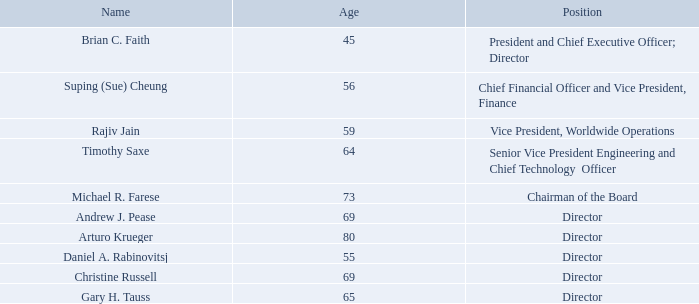Information About Our Executive Officers and Directors
Our executive officers are appointed by, and serve at the discretion of, our Board of Directors. There are no family relationships among our directors and officers.
The following table sets forth certain information concerning our current executive officers and directors as of March 13, 2020:
Brian C. Faith joined QuickLogic in June 1996. Mr. Faith has served as our President and Chief Executive Officer since June 2016 after having served as Vice President of Worldwide Marketing and Vice President of Worldwide Sales & Marketing between 2008 and 2016. Mr. Faith during the last 21 years has held a variety of managerial and executive leadership positions in engineering, product line management, marketing and sales. Mr. Faith has also served as the board member of the Global Semiconductor Alliance (GSA), the Chairman of the Marketing Committee for the CE-ATA Organization. He holds a B.S. degree in Computer Engineering from Santa Clara University and was an Adjunct Lecturer at Santa Clara University for Programmable Logic courses.
Suping (Sue) Cheung (Ph.D.) joined QuickLogic in May 2007. Dr. Cheung has served as our Chief Financial Officer, Vice President of Finance, Chief Accounting Officer, and Principal Accounting Officer since May 2015, Corporate Controller from 2007 to 2018. Prior to joining QuickLogic, Dr. Cheung was a Senior Manager of SEC Reporting, Technical Accounting and International Consolidation at Dell SonicWALL from 2006 to 2007 and was the Senior Accounting Manager at VeriFone System, Inc. from 2005 to 2006. Prior to 2005, Dr. Cheung held various senior accounting and financial management roles in both publicly traded and privately held companies. Dr. Cheung began her career with PricewaterhouseCoopers (PWC) where she served as an auditor and as a tax consultant. Dr. Cheung holds a Ph.D. in Business Administration and a Masters in Accounting from the Florida International University in Miami. She is a Certified Public Accountant.
Rajiv Jain joined QuickLogic in August 1992. Mr. Jain has served as our Vice President of Worldwide Operations since April 2014. Prior to this role, Mr. Jain served as QuickLogic’s Senior Director of Operations and Development Engineering from 2011 to 2014, Senior Director of System Solutions and Process Technology from 2009 to 2011, Director of Process Technology from 1997 to 2009, and Senior Process Technologist from 1992 to 1997. Prior to joining QuickLogic, Mr. Jain was a Senior Yield Engineer at National Semiconductor from 1991 to 1992, where he focused on BiCMOS product yield improvements, and at Monolithic Memories from 1985 to 1988, where he focused on BiPolar product yield and engineering wafer sort improvements. Mr. Jain holds a Master’s degree in Chemical Engineering from the University of California, Berkeley and a B.S. degree in Chemical Engineering from the University of Illinois, Champaign/Urbana.
Timothy Saxe (Ph.D.) joined QuickLogic in May 2001. Dr. Saxe has served as our Senior Vice President of Engineering and Chief Technology Officer since August 2016 and Senior Vice President and Chief Technology Officer since November 2008. Previously, Dr. Saxe has held a variety of executive leadership positions in QuickLogic including Vice President of Engineering and Vice President of Software Engineering. Dr. Saxe was Vice President of FLASH Engineering at Actel Corporation, a semiconductor manufacturing company, from November 2000 to February 2001. Dr. Saxe joined GateField Corporation, a design verification tools and services company formerly known as Zycad, in June 1983 and was a founder of their semiconductor manufacturing division in 1993. Dr. Saxe became GateField’s Chief Executive Officer in February 1999 and served in that capacity until Actel Corporation acquired GateField in November 2000. Dr. Saxe holds a B.S.E.E. degree from North Carolina State University, and an M.S.E.E. degree and a Ph.D. in Electrical Engineering from Stanford University.
Information regarding the backgrounds of our directors is set forth under the caption “Proposal One, Election of Directors” in our Proxy Statement, which information is incorporated herein by reference.
What are the respective names of the company's President and Chief Financial Officer? Brian c. faith, suping (sue) cheung. What are the respective names of the company's Vice President of Worldwide Operations and Chief Executive Officer? Rajiv jain, brian c. faith. What are the respective names of the company's Chief Financial Officer and Vice President of Worldwide Operations? Suping (sue) cheung, rajiv jain. What is the average age of the company's President and Vice President of Worldwide Operations? (45 + 59)/2 
Answer: 52. What is the average age of the company's President and Chief Financial Officer? (45 + 56)/2 
Answer: 50.5. What is the average age of the company's Vice President of Worldwide Operations and Chief Technology Officer? (59 + 64)/2 
Answer: 61.5. 